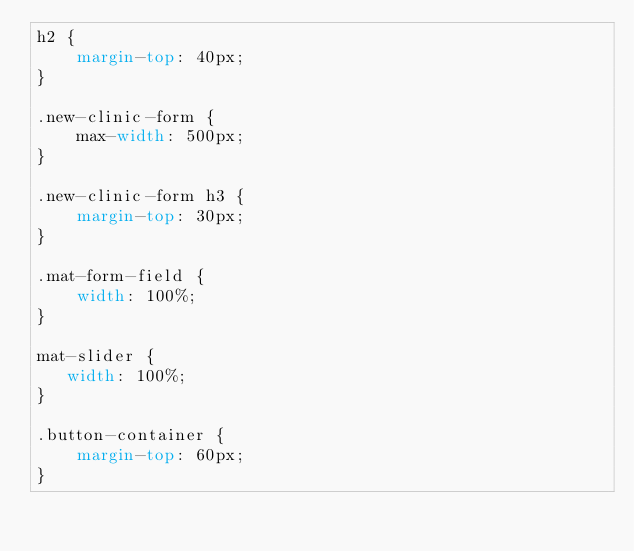<code> <loc_0><loc_0><loc_500><loc_500><_CSS_>h2 {
    margin-top: 40px;
}

.new-clinic-form {
    max-width: 500px;
}

.new-clinic-form h3 {
    margin-top: 30px;
}

.mat-form-field {
    width: 100%;
}

mat-slider {
   width: 100%;
}

.button-container {
    margin-top: 60px;
}</code> 